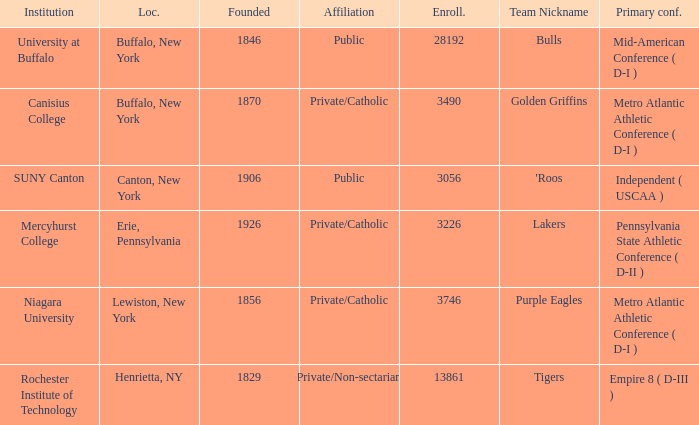What was the enrollment of the school founded in 1846? 28192.0. 